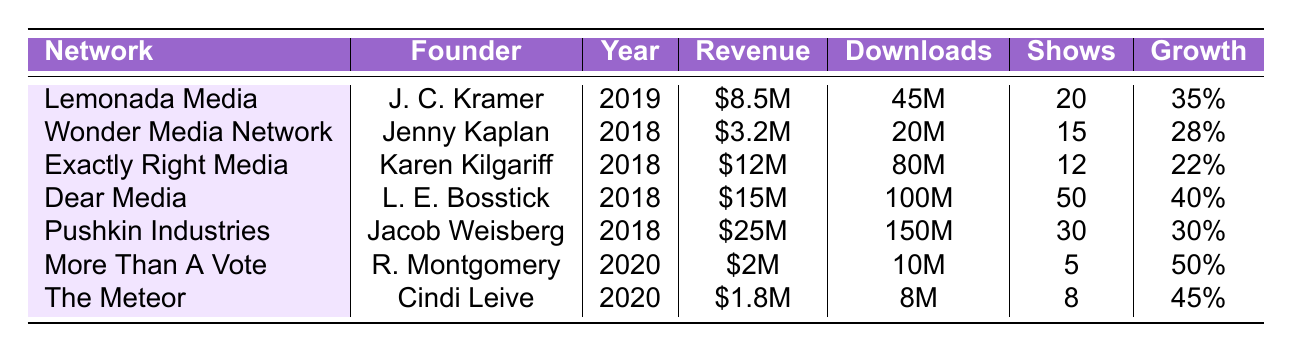What is the annual revenue of Lemonada Media? According to the table, Lemonada Media's annual revenue for 2022 is listed as \$8.5 million.
Answer: \$8.5 million Which network has the highest number of shows? The table shows that Dear Media has the highest number of shows, with a total of 50 shows.
Answer: Dear Media What was the total number of downloads for Exactly Right Media in 2022? The total downloads for Exactly Right Media in 2022, as per the table, is 80 million.
Answer: 80 million Calculate the average growth rate of the podcast networks founded in 2018. The growth rates for the networks founded in 2018 are 0.28, 0.22, 0.40, and 0.30. Summing these gives 1.20, and dividing by 4 (the number of networks) results in an average growth rate of 0.30.
Answer: 0.30 Is the annual revenue of More Than A Vote greater than that of The Meteor? More Than A Vote has an annual revenue of \$2 million, while The Meteor has \$1.8 million, which means More Than A Vote has a greater revenue.
Answer: Yes What is the growth rate of the network with the least annual revenue? The network with the least annual revenue is The Meteor with \$1.8 million, and its growth rate is 0.45.
Answer: 0.45 How many downloads did Dear Media receive? According to the table, Dear Media received total downloads of 100 million in 2022.
Answer: 100 million Which network was founded more recently, More Than A Vote or The Meteor? More Than A Vote was founded in 2020, while The Meteor was also founded in 2020. Therefore, they were founded in the same year.
Answer: They were founded in the same year Calculate the total annual revenue of all networks founded in 2018. The annual revenues for networks founded in 2018 are \$3.2 million (Wonder Media Network), \$12 million (Exactly Right Media), \$15 million (Dear Media), and \$25 million (Pushkin Industries). Summing these gives \$55.2 million.
Answer: \$55.2 million What is the top show for the Pushkin Industries network? The table indicates that the top show for Pushkin Industries is "Against the Rules."
Answer: Against the Rules 